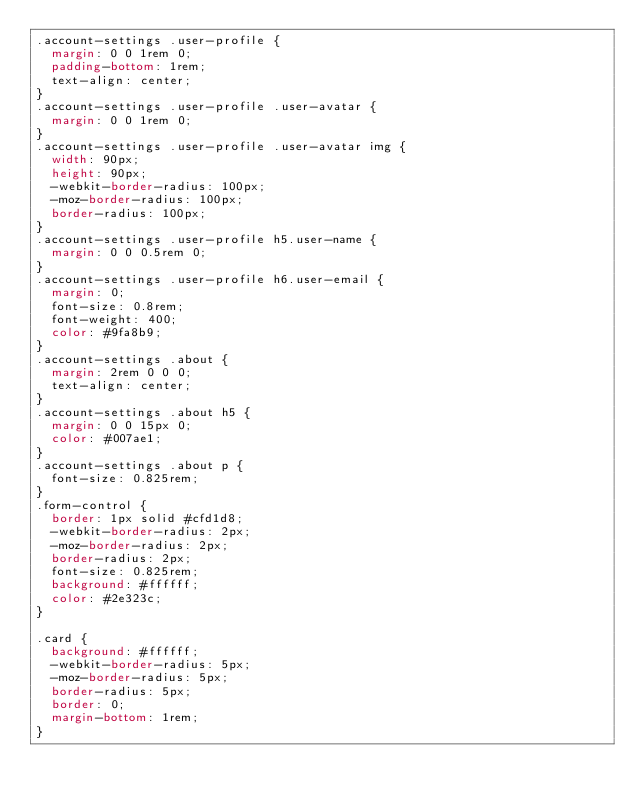<code> <loc_0><loc_0><loc_500><loc_500><_CSS_>.account-settings .user-profile {
  margin: 0 0 1rem 0;
  padding-bottom: 1rem;
  text-align: center;
}
.account-settings .user-profile .user-avatar {
  margin: 0 0 1rem 0;
}
.account-settings .user-profile .user-avatar img {
  width: 90px;
  height: 90px;
  -webkit-border-radius: 100px;
  -moz-border-radius: 100px;
  border-radius: 100px;
}
.account-settings .user-profile h5.user-name {
  margin: 0 0 0.5rem 0;
}
.account-settings .user-profile h6.user-email {
  margin: 0;
  font-size: 0.8rem;
  font-weight: 400;
  color: #9fa8b9;
}
.account-settings .about {
  margin: 2rem 0 0 0;
  text-align: center;
}
.account-settings .about h5 {
  margin: 0 0 15px 0;
  color: #007ae1;
}
.account-settings .about p {
  font-size: 0.825rem;
}
.form-control {
  border: 1px solid #cfd1d8;
  -webkit-border-radius: 2px;
  -moz-border-radius: 2px;
  border-radius: 2px;
  font-size: 0.825rem;
  background: #ffffff;
  color: #2e323c;
}

.card {
  background: #ffffff;
  -webkit-border-radius: 5px;
  -moz-border-radius: 5px;
  border-radius: 5px;
  border: 0;
  margin-bottom: 1rem;
}
</code> 